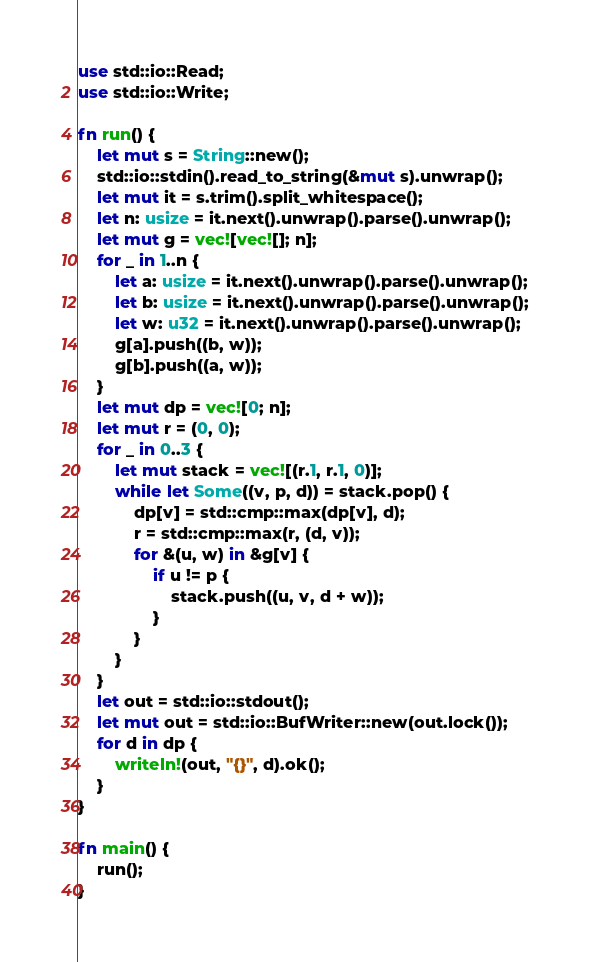Convert code to text. <code><loc_0><loc_0><loc_500><loc_500><_Rust_>use std::io::Read;
use std::io::Write;

fn run() {
    let mut s = String::new();
    std::io::stdin().read_to_string(&mut s).unwrap();
    let mut it = s.trim().split_whitespace();
    let n: usize = it.next().unwrap().parse().unwrap();
    let mut g = vec![vec![]; n];
    for _ in 1..n {
        let a: usize = it.next().unwrap().parse().unwrap();
        let b: usize = it.next().unwrap().parse().unwrap();
        let w: u32 = it.next().unwrap().parse().unwrap();
        g[a].push((b, w));
        g[b].push((a, w));
    }
    let mut dp = vec![0; n];
    let mut r = (0, 0);
    for _ in 0..3 {
        let mut stack = vec![(r.1, r.1, 0)];
        while let Some((v, p, d)) = stack.pop() {
            dp[v] = std::cmp::max(dp[v], d);
            r = std::cmp::max(r, (d, v));
            for &(u, w) in &g[v] {
                if u != p {
                    stack.push((u, v, d + w));
                }
            }
        }
    }
    let out = std::io::stdout();
    let mut out = std::io::BufWriter::new(out.lock());
    for d in dp {
        writeln!(out, "{}", d).ok();
    }
}

fn main() {
    run();
}

</code> 